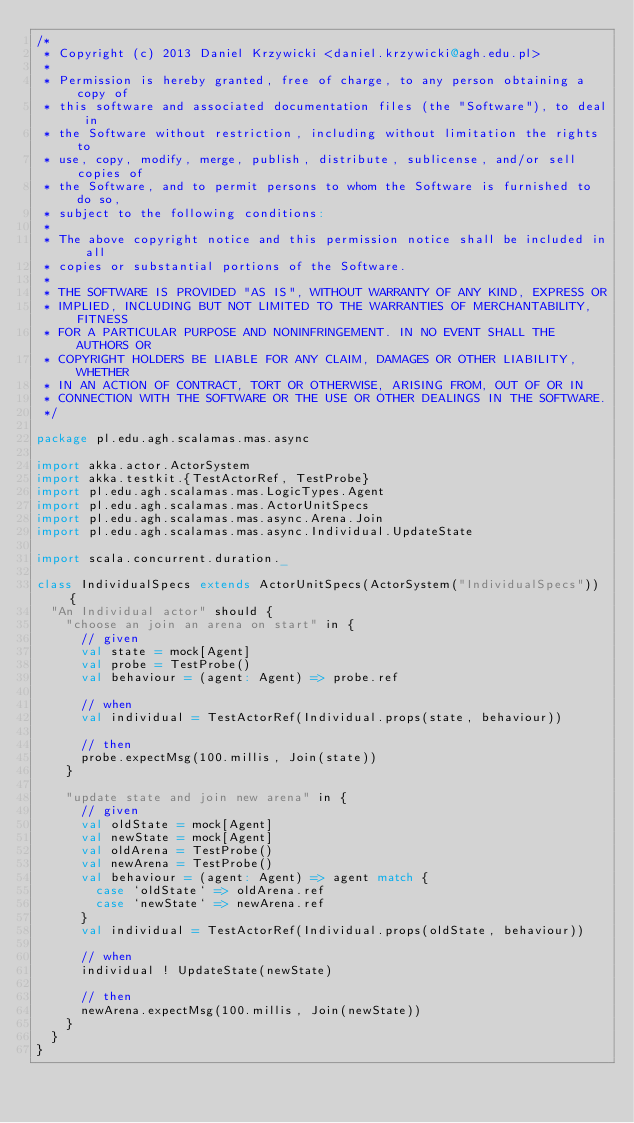<code> <loc_0><loc_0><loc_500><loc_500><_Scala_>/*
 * Copyright (c) 2013 Daniel Krzywicki <daniel.krzywicki@agh.edu.pl>
 *
 * Permission is hereby granted, free of charge, to any person obtaining a copy of
 * this software and associated documentation files (the "Software"), to deal in
 * the Software without restriction, including without limitation the rights to
 * use, copy, modify, merge, publish, distribute, sublicense, and/or sell copies of
 * the Software, and to permit persons to whom the Software is furnished to do so,
 * subject to the following conditions:
 *
 * The above copyright notice and this permission notice shall be included in all
 * copies or substantial portions of the Software.
 *
 * THE SOFTWARE IS PROVIDED "AS IS", WITHOUT WARRANTY OF ANY KIND, EXPRESS OR
 * IMPLIED, INCLUDING BUT NOT LIMITED TO THE WARRANTIES OF MERCHANTABILITY, FITNESS
 * FOR A PARTICULAR PURPOSE AND NONINFRINGEMENT. IN NO EVENT SHALL THE AUTHORS OR
 * COPYRIGHT HOLDERS BE LIABLE FOR ANY CLAIM, DAMAGES OR OTHER LIABILITY, WHETHER
 * IN AN ACTION OF CONTRACT, TORT OR OTHERWISE, ARISING FROM, OUT OF OR IN
 * CONNECTION WITH THE SOFTWARE OR THE USE OR OTHER DEALINGS IN THE SOFTWARE.
 */

package pl.edu.agh.scalamas.mas.async

import akka.actor.ActorSystem
import akka.testkit.{TestActorRef, TestProbe}
import pl.edu.agh.scalamas.mas.LogicTypes.Agent
import pl.edu.agh.scalamas.mas.ActorUnitSpecs
import pl.edu.agh.scalamas.mas.async.Arena.Join
import pl.edu.agh.scalamas.mas.async.Individual.UpdateState

import scala.concurrent.duration._

class IndividualSpecs extends ActorUnitSpecs(ActorSystem("IndividualSpecs")) {
  "An Individual actor" should {
    "choose an join an arena on start" in {
      // given
      val state = mock[Agent]
      val probe = TestProbe()
      val behaviour = (agent: Agent) => probe.ref

      // when
      val individual = TestActorRef(Individual.props(state, behaviour))

      // then
      probe.expectMsg(100.millis, Join(state))
    }

    "update state and join new arena" in {
      // given
      val oldState = mock[Agent]
      val newState = mock[Agent]
      val oldArena = TestProbe()
      val newArena = TestProbe()
      val behaviour = (agent: Agent) => agent match {
        case `oldState` => oldArena.ref
        case `newState` => newArena.ref
      }
      val individual = TestActorRef(Individual.props(oldState, behaviour))

      // when
      individual ! UpdateState(newState)

      // then
      newArena.expectMsg(100.millis, Join(newState))
    }
  }
}</code> 